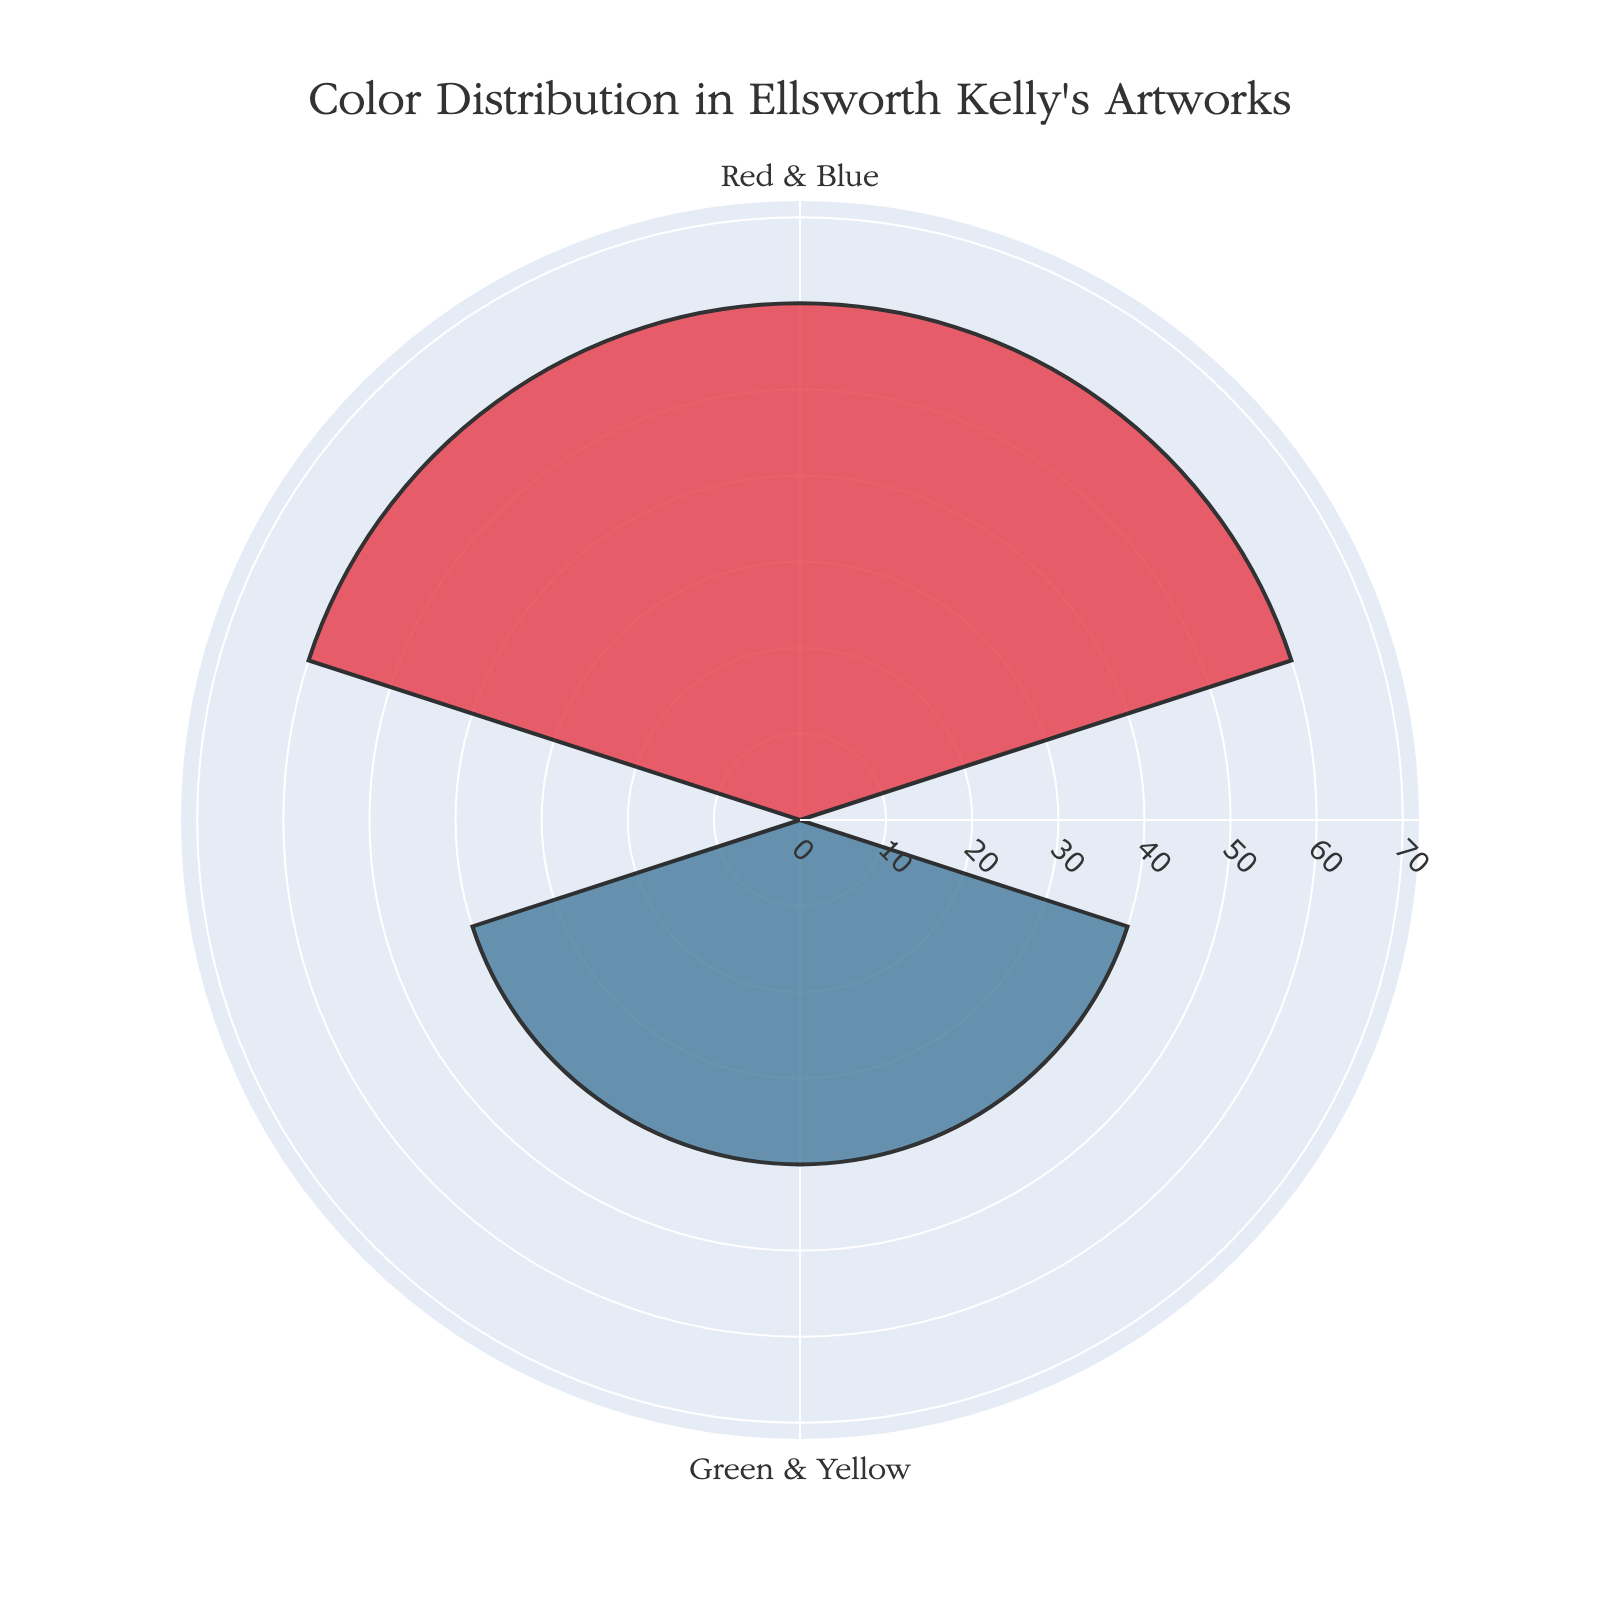What's the title of the chart? The title is usually found at the top of the chart and provides a brief description of the data being visualized. In this case, the title is clearly visible at the top of the rose chart.
Answer: "Color Distribution in Ellsworth Kelly's Artworks" How many color groups are shown in the chart? By observing the sectors or bars in the rose chart, we can count the number of distinct groups. Each bar on the chart represents a unique color group.
Answer: 3 Which color group has the highest percentage? The largest bar in the rose chart corresponds to the color group with the highest percentage. By comparing the length of each bar, we can identify the one with the maximum value.
Answer: Blue & Yellow What is the percentage sum of the color groups Red and Green together? To find the total percentage of Red and Green, we simply add their individual percentages. The chart shows these values directly.
Answer: 45% Compare the percentage of Red & Blue and Blue & Yellow, and state which one is greater. By looking at the chart, we can compare the lengths of the respective bars. The bar with the longer length corresponds to the greater percentage.
Answer: Blue & Yellow How do the radial axis ranges affect the visualization? The radial axis range is set from 0 to slightly above the maximum value to provide a clear visualization. This choice ensures that all bars are properly scaled and easily distinguishable.
Answer: It enhances clarity Describe the artistic choice in color selection for this chart. The chart uses deep, vibrant colors that not only distinguish different groups clearly but also resonate with the abstract and bold style typical of Ellsworth Kelly's artwork.
Answer: Bold and vibrant 